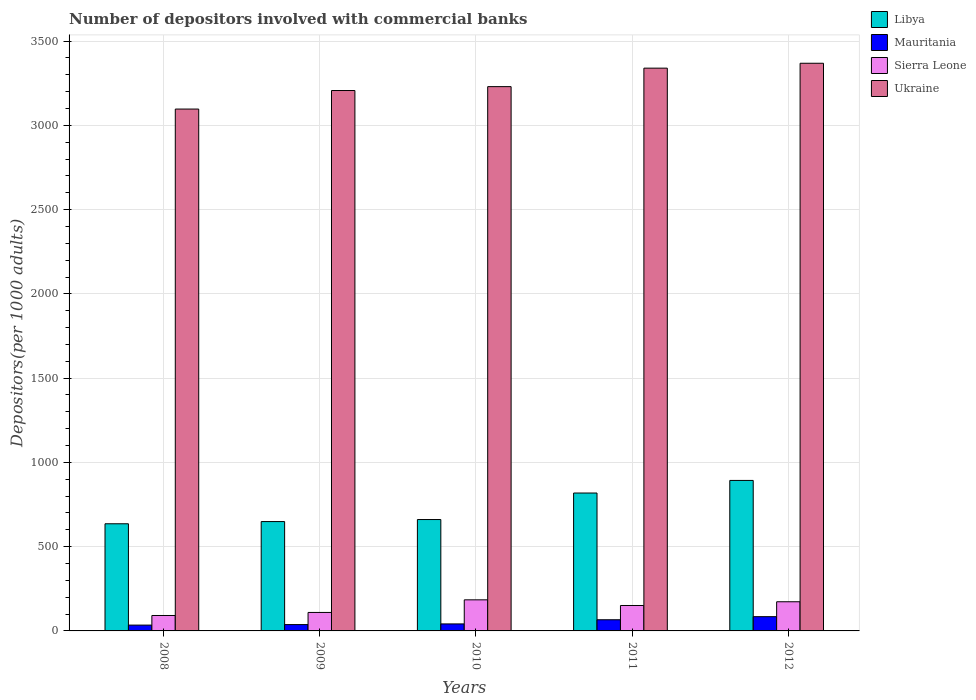How many different coloured bars are there?
Your answer should be compact. 4. Are the number of bars per tick equal to the number of legend labels?
Make the answer very short. Yes. Are the number of bars on each tick of the X-axis equal?
Provide a short and direct response. Yes. How many bars are there on the 3rd tick from the left?
Give a very brief answer. 4. What is the number of depositors involved with commercial banks in Libya in 2008?
Your answer should be very brief. 635.76. Across all years, what is the maximum number of depositors involved with commercial banks in Libya?
Offer a terse response. 892.96. Across all years, what is the minimum number of depositors involved with commercial banks in Mauritania?
Provide a succinct answer. 34.52. What is the total number of depositors involved with commercial banks in Libya in the graph?
Keep it short and to the point. 3656.76. What is the difference between the number of depositors involved with commercial banks in Libya in 2008 and that in 2012?
Offer a terse response. -257.2. What is the difference between the number of depositors involved with commercial banks in Sierra Leone in 2008 and the number of depositors involved with commercial banks in Ukraine in 2009?
Keep it short and to the point. -3115.07. What is the average number of depositors involved with commercial banks in Libya per year?
Your answer should be compact. 731.35. In the year 2009, what is the difference between the number of depositors involved with commercial banks in Ukraine and number of depositors involved with commercial banks in Libya?
Your answer should be very brief. 2557.78. What is the ratio of the number of depositors involved with commercial banks in Libya in 2008 to that in 2010?
Provide a succinct answer. 0.96. Is the number of depositors involved with commercial banks in Mauritania in 2009 less than that in 2012?
Your response must be concise. Yes. Is the difference between the number of depositors involved with commercial banks in Ukraine in 2010 and 2011 greater than the difference between the number of depositors involved with commercial banks in Libya in 2010 and 2011?
Offer a very short reply. Yes. What is the difference between the highest and the second highest number of depositors involved with commercial banks in Ukraine?
Give a very brief answer. 28.98. What is the difference between the highest and the lowest number of depositors involved with commercial banks in Sierra Leone?
Your answer should be very brief. 92.89. Is the sum of the number of depositors involved with commercial banks in Libya in 2008 and 2010 greater than the maximum number of depositors involved with commercial banks in Sierra Leone across all years?
Offer a very short reply. Yes. Is it the case that in every year, the sum of the number of depositors involved with commercial banks in Mauritania and number of depositors involved with commercial banks in Ukraine is greater than the sum of number of depositors involved with commercial banks in Libya and number of depositors involved with commercial banks in Sierra Leone?
Your response must be concise. Yes. What does the 3rd bar from the left in 2010 represents?
Keep it short and to the point. Sierra Leone. What does the 4th bar from the right in 2009 represents?
Your response must be concise. Libya. Is it the case that in every year, the sum of the number of depositors involved with commercial banks in Sierra Leone and number of depositors involved with commercial banks in Ukraine is greater than the number of depositors involved with commercial banks in Libya?
Provide a succinct answer. Yes. How many years are there in the graph?
Your answer should be very brief. 5. Are the values on the major ticks of Y-axis written in scientific E-notation?
Your answer should be compact. No. Does the graph contain grids?
Your response must be concise. Yes. How many legend labels are there?
Provide a succinct answer. 4. What is the title of the graph?
Keep it short and to the point. Number of depositors involved with commercial banks. Does "United Kingdom" appear as one of the legend labels in the graph?
Offer a terse response. No. What is the label or title of the X-axis?
Your answer should be compact. Years. What is the label or title of the Y-axis?
Your response must be concise. Depositors(per 1000 adults). What is the Depositors(per 1000 adults) in Libya in 2008?
Make the answer very short. 635.76. What is the Depositors(per 1000 adults) in Mauritania in 2008?
Provide a succinct answer. 34.52. What is the Depositors(per 1000 adults) of Sierra Leone in 2008?
Give a very brief answer. 91.57. What is the Depositors(per 1000 adults) of Ukraine in 2008?
Keep it short and to the point. 3096.67. What is the Depositors(per 1000 adults) in Libya in 2009?
Your answer should be compact. 648.86. What is the Depositors(per 1000 adults) of Mauritania in 2009?
Keep it short and to the point. 37.6. What is the Depositors(per 1000 adults) in Sierra Leone in 2009?
Ensure brevity in your answer.  109.66. What is the Depositors(per 1000 adults) in Ukraine in 2009?
Offer a very short reply. 3206.64. What is the Depositors(per 1000 adults) in Libya in 2010?
Your response must be concise. 660.95. What is the Depositors(per 1000 adults) in Mauritania in 2010?
Ensure brevity in your answer.  41.54. What is the Depositors(per 1000 adults) of Sierra Leone in 2010?
Make the answer very short. 184.46. What is the Depositors(per 1000 adults) in Ukraine in 2010?
Offer a very short reply. 3229.69. What is the Depositors(per 1000 adults) of Libya in 2011?
Provide a short and direct response. 818.23. What is the Depositors(per 1000 adults) in Mauritania in 2011?
Make the answer very short. 66.23. What is the Depositors(per 1000 adults) in Sierra Leone in 2011?
Provide a short and direct response. 150.85. What is the Depositors(per 1000 adults) of Ukraine in 2011?
Give a very brief answer. 3339.41. What is the Depositors(per 1000 adults) in Libya in 2012?
Your response must be concise. 892.96. What is the Depositors(per 1000 adults) in Mauritania in 2012?
Your answer should be compact. 84.61. What is the Depositors(per 1000 adults) of Sierra Leone in 2012?
Your response must be concise. 173.07. What is the Depositors(per 1000 adults) in Ukraine in 2012?
Give a very brief answer. 3368.39. Across all years, what is the maximum Depositors(per 1000 adults) of Libya?
Give a very brief answer. 892.96. Across all years, what is the maximum Depositors(per 1000 adults) of Mauritania?
Keep it short and to the point. 84.61. Across all years, what is the maximum Depositors(per 1000 adults) in Sierra Leone?
Offer a terse response. 184.46. Across all years, what is the maximum Depositors(per 1000 adults) of Ukraine?
Your answer should be compact. 3368.39. Across all years, what is the minimum Depositors(per 1000 adults) in Libya?
Your answer should be compact. 635.76. Across all years, what is the minimum Depositors(per 1000 adults) in Mauritania?
Ensure brevity in your answer.  34.52. Across all years, what is the minimum Depositors(per 1000 adults) of Sierra Leone?
Your answer should be very brief. 91.57. Across all years, what is the minimum Depositors(per 1000 adults) in Ukraine?
Your answer should be compact. 3096.67. What is the total Depositors(per 1000 adults) in Libya in the graph?
Provide a succinct answer. 3656.76. What is the total Depositors(per 1000 adults) of Mauritania in the graph?
Make the answer very short. 264.5. What is the total Depositors(per 1000 adults) of Sierra Leone in the graph?
Give a very brief answer. 709.61. What is the total Depositors(per 1000 adults) of Ukraine in the graph?
Your answer should be compact. 1.62e+04. What is the difference between the Depositors(per 1000 adults) in Libya in 2008 and that in 2009?
Keep it short and to the point. -13.1. What is the difference between the Depositors(per 1000 adults) of Mauritania in 2008 and that in 2009?
Offer a very short reply. -3.09. What is the difference between the Depositors(per 1000 adults) in Sierra Leone in 2008 and that in 2009?
Your answer should be very brief. -18.09. What is the difference between the Depositors(per 1000 adults) in Ukraine in 2008 and that in 2009?
Keep it short and to the point. -109.97. What is the difference between the Depositors(per 1000 adults) of Libya in 2008 and that in 2010?
Ensure brevity in your answer.  -25.19. What is the difference between the Depositors(per 1000 adults) of Mauritania in 2008 and that in 2010?
Give a very brief answer. -7.02. What is the difference between the Depositors(per 1000 adults) in Sierra Leone in 2008 and that in 2010?
Your answer should be very brief. -92.89. What is the difference between the Depositors(per 1000 adults) of Ukraine in 2008 and that in 2010?
Provide a short and direct response. -133.02. What is the difference between the Depositors(per 1000 adults) in Libya in 2008 and that in 2011?
Provide a succinct answer. -182.47. What is the difference between the Depositors(per 1000 adults) in Mauritania in 2008 and that in 2011?
Your answer should be compact. -31.71. What is the difference between the Depositors(per 1000 adults) in Sierra Leone in 2008 and that in 2011?
Offer a very short reply. -59.28. What is the difference between the Depositors(per 1000 adults) of Ukraine in 2008 and that in 2011?
Your answer should be compact. -242.74. What is the difference between the Depositors(per 1000 adults) of Libya in 2008 and that in 2012?
Keep it short and to the point. -257.2. What is the difference between the Depositors(per 1000 adults) in Mauritania in 2008 and that in 2012?
Your answer should be very brief. -50.1. What is the difference between the Depositors(per 1000 adults) of Sierra Leone in 2008 and that in 2012?
Your answer should be very brief. -81.5. What is the difference between the Depositors(per 1000 adults) of Ukraine in 2008 and that in 2012?
Offer a very short reply. -271.72. What is the difference between the Depositors(per 1000 adults) in Libya in 2009 and that in 2010?
Your response must be concise. -12.09. What is the difference between the Depositors(per 1000 adults) of Mauritania in 2009 and that in 2010?
Keep it short and to the point. -3.93. What is the difference between the Depositors(per 1000 adults) of Sierra Leone in 2009 and that in 2010?
Your answer should be compact. -74.8. What is the difference between the Depositors(per 1000 adults) in Ukraine in 2009 and that in 2010?
Ensure brevity in your answer.  -23.06. What is the difference between the Depositors(per 1000 adults) in Libya in 2009 and that in 2011?
Your response must be concise. -169.37. What is the difference between the Depositors(per 1000 adults) of Mauritania in 2009 and that in 2011?
Ensure brevity in your answer.  -28.63. What is the difference between the Depositors(per 1000 adults) in Sierra Leone in 2009 and that in 2011?
Make the answer very short. -41.18. What is the difference between the Depositors(per 1000 adults) of Ukraine in 2009 and that in 2011?
Offer a terse response. -132.77. What is the difference between the Depositors(per 1000 adults) in Libya in 2009 and that in 2012?
Ensure brevity in your answer.  -244.1. What is the difference between the Depositors(per 1000 adults) in Mauritania in 2009 and that in 2012?
Keep it short and to the point. -47.01. What is the difference between the Depositors(per 1000 adults) of Sierra Leone in 2009 and that in 2012?
Provide a succinct answer. -63.41. What is the difference between the Depositors(per 1000 adults) in Ukraine in 2009 and that in 2012?
Your response must be concise. -161.75. What is the difference between the Depositors(per 1000 adults) in Libya in 2010 and that in 2011?
Ensure brevity in your answer.  -157.27. What is the difference between the Depositors(per 1000 adults) in Mauritania in 2010 and that in 2011?
Provide a succinct answer. -24.69. What is the difference between the Depositors(per 1000 adults) of Sierra Leone in 2010 and that in 2011?
Your answer should be compact. 33.62. What is the difference between the Depositors(per 1000 adults) of Ukraine in 2010 and that in 2011?
Give a very brief answer. -109.71. What is the difference between the Depositors(per 1000 adults) in Libya in 2010 and that in 2012?
Your answer should be compact. -232. What is the difference between the Depositors(per 1000 adults) of Mauritania in 2010 and that in 2012?
Offer a terse response. -43.07. What is the difference between the Depositors(per 1000 adults) of Sierra Leone in 2010 and that in 2012?
Make the answer very short. 11.39. What is the difference between the Depositors(per 1000 adults) in Ukraine in 2010 and that in 2012?
Provide a short and direct response. -138.7. What is the difference between the Depositors(per 1000 adults) in Libya in 2011 and that in 2012?
Offer a terse response. -74.73. What is the difference between the Depositors(per 1000 adults) of Mauritania in 2011 and that in 2012?
Ensure brevity in your answer.  -18.38. What is the difference between the Depositors(per 1000 adults) in Sierra Leone in 2011 and that in 2012?
Provide a short and direct response. -22.22. What is the difference between the Depositors(per 1000 adults) of Ukraine in 2011 and that in 2012?
Offer a terse response. -28.98. What is the difference between the Depositors(per 1000 adults) of Libya in 2008 and the Depositors(per 1000 adults) of Mauritania in 2009?
Make the answer very short. 598.16. What is the difference between the Depositors(per 1000 adults) of Libya in 2008 and the Depositors(per 1000 adults) of Sierra Leone in 2009?
Keep it short and to the point. 526.1. What is the difference between the Depositors(per 1000 adults) of Libya in 2008 and the Depositors(per 1000 adults) of Ukraine in 2009?
Your response must be concise. -2570.88. What is the difference between the Depositors(per 1000 adults) in Mauritania in 2008 and the Depositors(per 1000 adults) in Sierra Leone in 2009?
Your answer should be compact. -75.15. What is the difference between the Depositors(per 1000 adults) in Mauritania in 2008 and the Depositors(per 1000 adults) in Ukraine in 2009?
Make the answer very short. -3172.12. What is the difference between the Depositors(per 1000 adults) of Sierra Leone in 2008 and the Depositors(per 1000 adults) of Ukraine in 2009?
Give a very brief answer. -3115.07. What is the difference between the Depositors(per 1000 adults) in Libya in 2008 and the Depositors(per 1000 adults) in Mauritania in 2010?
Provide a short and direct response. 594.22. What is the difference between the Depositors(per 1000 adults) in Libya in 2008 and the Depositors(per 1000 adults) in Sierra Leone in 2010?
Provide a short and direct response. 451.3. What is the difference between the Depositors(per 1000 adults) of Libya in 2008 and the Depositors(per 1000 adults) of Ukraine in 2010?
Give a very brief answer. -2593.93. What is the difference between the Depositors(per 1000 adults) of Mauritania in 2008 and the Depositors(per 1000 adults) of Sierra Leone in 2010?
Make the answer very short. -149.95. What is the difference between the Depositors(per 1000 adults) in Mauritania in 2008 and the Depositors(per 1000 adults) in Ukraine in 2010?
Your answer should be very brief. -3195.18. What is the difference between the Depositors(per 1000 adults) of Sierra Leone in 2008 and the Depositors(per 1000 adults) of Ukraine in 2010?
Your response must be concise. -3138.12. What is the difference between the Depositors(per 1000 adults) in Libya in 2008 and the Depositors(per 1000 adults) in Mauritania in 2011?
Your answer should be very brief. 569.53. What is the difference between the Depositors(per 1000 adults) in Libya in 2008 and the Depositors(per 1000 adults) in Sierra Leone in 2011?
Keep it short and to the point. 484.91. What is the difference between the Depositors(per 1000 adults) of Libya in 2008 and the Depositors(per 1000 adults) of Ukraine in 2011?
Offer a terse response. -2703.64. What is the difference between the Depositors(per 1000 adults) of Mauritania in 2008 and the Depositors(per 1000 adults) of Sierra Leone in 2011?
Ensure brevity in your answer.  -116.33. What is the difference between the Depositors(per 1000 adults) of Mauritania in 2008 and the Depositors(per 1000 adults) of Ukraine in 2011?
Your answer should be compact. -3304.89. What is the difference between the Depositors(per 1000 adults) of Sierra Leone in 2008 and the Depositors(per 1000 adults) of Ukraine in 2011?
Ensure brevity in your answer.  -3247.84. What is the difference between the Depositors(per 1000 adults) in Libya in 2008 and the Depositors(per 1000 adults) in Mauritania in 2012?
Provide a short and direct response. 551.15. What is the difference between the Depositors(per 1000 adults) in Libya in 2008 and the Depositors(per 1000 adults) in Sierra Leone in 2012?
Provide a short and direct response. 462.69. What is the difference between the Depositors(per 1000 adults) in Libya in 2008 and the Depositors(per 1000 adults) in Ukraine in 2012?
Your answer should be compact. -2732.63. What is the difference between the Depositors(per 1000 adults) in Mauritania in 2008 and the Depositors(per 1000 adults) in Sierra Leone in 2012?
Make the answer very short. -138.55. What is the difference between the Depositors(per 1000 adults) of Mauritania in 2008 and the Depositors(per 1000 adults) of Ukraine in 2012?
Provide a succinct answer. -3333.87. What is the difference between the Depositors(per 1000 adults) of Sierra Leone in 2008 and the Depositors(per 1000 adults) of Ukraine in 2012?
Your answer should be very brief. -3276.82. What is the difference between the Depositors(per 1000 adults) of Libya in 2009 and the Depositors(per 1000 adults) of Mauritania in 2010?
Offer a very short reply. 607.32. What is the difference between the Depositors(per 1000 adults) of Libya in 2009 and the Depositors(per 1000 adults) of Sierra Leone in 2010?
Your response must be concise. 464.4. What is the difference between the Depositors(per 1000 adults) of Libya in 2009 and the Depositors(per 1000 adults) of Ukraine in 2010?
Your answer should be very brief. -2580.83. What is the difference between the Depositors(per 1000 adults) of Mauritania in 2009 and the Depositors(per 1000 adults) of Sierra Leone in 2010?
Your answer should be compact. -146.86. What is the difference between the Depositors(per 1000 adults) of Mauritania in 2009 and the Depositors(per 1000 adults) of Ukraine in 2010?
Provide a succinct answer. -3192.09. What is the difference between the Depositors(per 1000 adults) in Sierra Leone in 2009 and the Depositors(per 1000 adults) in Ukraine in 2010?
Give a very brief answer. -3120.03. What is the difference between the Depositors(per 1000 adults) of Libya in 2009 and the Depositors(per 1000 adults) of Mauritania in 2011?
Offer a very short reply. 582.63. What is the difference between the Depositors(per 1000 adults) of Libya in 2009 and the Depositors(per 1000 adults) of Sierra Leone in 2011?
Your response must be concise. 498.01. What is the difference between the Depositors(per 1000 adults) in Libya in 2009 and the Depositors(per 1000 adults) in Ukraine in 2011?
Make the answer very short. -2690.54. What is the difference between the Depositors(per 1000 adults) of Mauritania in 2009 and the Depositors(per 1000 adults) of Sierra Leone in 2011?
Your response must be concise. -113.24. What is the difference between the Depositors(per 1000 adults) of Mauritania in 2009 and the Depositors(per 1000 adults) of Ukraine in 2011?
Provide a succinct answer. -3301.8. What is the difference between the Depositors(per 1000 adults) of Sierra Leone in 2009 and the Depositors(per 1000 adults) of Ukraine in 2011?
Your answer should be compact. -3229.74. What is the difference between the Depositors(per 1000 adults) of Libya in 2009 and the Depositors(per 1000 adults) of Mauritania in 2012?
Keep it short and to the point. 564.25. What is the difference between the Depositors(per 1000 adults) in Libya in 2009 and the Depositors(per 1000 adults) in Sierra Leone in 2012?
Keep it short and to the point. 475.79. What is the difference between the Depositors(per 1000 adults) in Libya in 2009 and the Depositors(per 1000 adults) in Ukraine in 2012?
Ensure brevity in your answer.  -2719.53. What is the difference between the Depositors(per 1000 adults) in Mauritania in 2009 and the Depositors(per 1000 adults) in Sierra Leone in 2012?
Give a very brief answer. -135.47. What is the difference between the Depositors(per 1000 adults) of Mauritania in 2009 and the Depositors(per 1000 adults) of Ukraine in 2012?
Your answer should be compact. -3330.79. What is the difference between the Depositors(per 1000 adults) in Sierra Leone in 2009 and the Depositors(per 1000 adults) in Ukraine in 2012?
Your answer should be compact. -3258.73. What is the difference between the Depositors(per 1000 adults) of Libya in 2010 and the Depositors(per 1000 adults) of Mauritania in 2011?
Your answer should be very brief. 594.72. What is the difference between the Depositors(per 1000 adults) in Libya in 2010 and the Depositors(per 1000 adults) in Sierra Leone in 2011?
Provide a succinct answer. 510.11. What is the difference between the Depositors(per 1000 adults) in Libya in 2010 and the Depositors(per 1000 adults) in Ukraine in 2011?
Provide a short and direct response. -2678.45. What is the difference between the Depositors(per 1000 adults) of Mauritania in 2010 and the Depositors(per 1000 adults) of Sierra Leone in 2011?
Keep it short and to the point. -109.31. What is the difference between the Depositors(per 1000 adults) in Mauritania in 2010 and the Depositors(per 1000 adults) in Ukraine in 2011?
Make the answer very short. -3297.87. What is the difference between the Depositors(per 1000 adults) in Sierra Leone in 2010 and the Depositors(per 1000 adults) in Ukraine in 2011?
Make the answer very short. -3154.94. What is the difference between the Depositors(per 1000 adults) of Libya in 2010 and the Depositors(per 1000 adults) of Mauritania in 2012?
Offer a terse response. 576.34. What is the difference between the Depositors(per 1000 adults) of Libya in 2010 and the Depositors(per 1000 adults) of Sierra Leone in 2012?
Keep it short and to the point. 487.88. What is the difference between the Depositors(per 1000 adults) of Libya in 2010 and the Depositors(per 1000 adults) of Ukraine in 2012?
Your answer should be compact. -2707.43. What is the difference between the Depositors(per 1000 adults) in Mauritania in 2010 and the Depositors(per 1000 adults) in Sierra Leone in 2012?
Offer a terse response. -131.53. What is the difference between the Depositors(per 1000 adults) in Mauritania in 2010 and the Depositors(per 1000 adults) in Ukraine in 2012?
Ensure brevity in your answer.  -3326.85. What is the difference between the Depositors(per 1000 adults) of Sierra Leone in 2010 and the Depositors(per 1000 adults) of Ukraine in 2012?
Offer a very short reply. -3183.93. What is the difference between the Depositors(per 1000 adults) in Libya in 2011 and the Depositors(per 1000 adults) in Mauritania in 2012?
Give a very brief answer. 733.62. What is the difference between the Depositors(per 1000 adults) of Libya in 2011 and the Depositors(per 1000 adults) of Sierra Leone in 2012?
Your answer should be compact. 645.16. What is the difference between the Depositors(per 1000 adults) of Libya in 2011 and the Depositors(per 1000 adults) of Ukraine in 2012?
Offer a terse response. -2550.16. What is the difference between the Depositors(per 1000 adults) of Mauritania in 2011 and the Depositors(per 1000 adults) of Sierra Leone in 2012?
Your response must be concise. -106.84. What is the difference between the Depositors(per 1000 adults) in Mauritania in 2011 and the Depositors(per 1000 adults) in Ukraine in 2012?
Offer a terse response. -3302.16. What is the difference between the Depositors(per 1000 adults) in Sierra Leone in 2011 and the Depositors(per 1000 adults) in Ukraine in 2012?
Your answer should be compact. -3217.54. What is the average Depositors(per 1000 adults) of Libya per year?
Keep it short and to the point. 731.35. What is the average Depositors(per 1000 adults) in Mauritania per year?
Give a very brief answer. 52.9. What is the average Depositors(per 1000 adults) of Sierra Leone per year?
Ensure brevity in your answer.  141.92. What is the average Depositors(per 1000 adults) in Ukraine per year?
Your answer should be very brief. 3248.16. In the year 2008, what is the difference between the Depositors(per 1000 adults) in Libya and Depositors(per 1000 adults) in Mauritania?
Ensure brevity in your answer.  601.24. In the year 2008, what is the difference between the Depositors(per 1000 adults) of Libya and Depositors(per 1000 adults) of Sierra Leone?
Your answer should be compact. 544.19. In the year 2008, what is the difference between the Depositors(per 1000 adults) of Libya and Depositors(per 1000 adults) of Ukraine?
Ensure brevity in your answer.  -2460.91. In the year 2008, what is the difference between the Depositors(per 1000 adults) in Mauritania and Depositors(per 1000 adults) in Sierra Leone?
Make the answer very short. -57.05. In the year 2008, what is the difference between the Depositors(per 1000 adults) in Mauritania and Depositors(per 1000 adults) in Ukraine?
Provide a short and direct response. -3062.15. In the year 2008, what is the difference between the Depositors(per 1000 adults) in Sierra Leone and Depositors(per 1000 adults) in Ukraine?
Your answer should be compact. -3005.1. In the year 2009, what is the difference between the Depositors(per 1000 adults) in Libya and Depositors(per 1000 adults) in Mauritania?
Provide a succinct answer. 611.26. In the year 2009, what is the difference between the Depositors(per 1000 adults) of Libya and Depositors(per 1000 adults) of Sierra Leone?
Keep it short and to the point. 539.2. In the year 2009, what is the difference between the Depositors(per 1000 adults) in Libya and Depositors(per 1000 adults) in Ukraine?
Ensure brevity in your answer.  -2557.78. In the year 2009, what is the difference between the Depositors(per 1000 adults) in Mauritania and Depositors(per 1000 adults) in Sierra Leone?
Offer a very short reply. -72.06. In the year 2009, what is the difference between the Depositors(per 1000 adults) in Mauritania and Depositors(per 1000 adults) in Ukraine?
Provide a succinct answer. -3169.03. In the year 2009, what is the difference between the Depositors(per 1000 adults) in Sierra Leone and Depositors(per 1000 adults) in Ukraine?
Provide a succinct answer. -3096.98. In the year 2010, what is the difference between the Depositors(per 1000 adults) of Libya and Depositors(per 1000 adults) of Mauritania?
Your response must be concise. 619.42. In the year 2010, what is the difference between the Depositors(per 1000 adults) of Libya and Depositors(per 1000 adults) of Sierra Leone?
Provide a succinct answer. 476.49. In the year 2010, what is the difference between the Depositors(per 1000 adults) of Libya and Depositors(per 1000 adults) of Ukraine?
Provide a short and direct response. -2568.74. In the year 2010, what is the difference between the Depositors(per 1000 adults) in Mauritania and Depositors(per 1000 adults) in Sierra Leone?
Your response must be concise. -142.93. In the year 2010, what is the difference between the Depositors(per 1000 adults) of Mauritania and Depositors(per 1000 adults) of Ukraine?
Offer a terse response. -3188.16. In the year 2010, what is the difference between the Depositors(per 1000 adults) of Sierra Leone and Depositors(per 1000 adults) of Ukraine?
Give a very brief answer. -3045.23. In the year 2011, what is the difference between the Depositors(per 1000 adults) in Libya and Depositors(per 1000 adults) in Mauritania?
Your response must be concise. 752. In the year 2011, what is the difference between the Depositors(per 1000 adults) in Libya and Depositors(per 1000 adults) in Sierra Leone?
Provide a short and direct response. 667.38. In the year 2011, what is the difference between the Depositors(per 1000 adults) in Libya and Depositors(per 1000 adults) in Ukraine?
Ensure brevity in your answer.  -2521.18. In the year 2011, what is the difference between the Depositors(per 1000 adults) in Mauritania and Depositors(per 1000 adults) in Sierra Leone?
Ensure brevity in your answer.  -84.62. In the year 2011, what is the difference between the Depositors(per 1000 adults) in Mauritania and Depositors(per 1000 adults) in Ukraine?
Ensure brevity in your answer.  -3273.18. In the year 2011, what is the difference between the Depositors(per 1000 adults) in Sierra Leone and Depositors(per 1000 adults) in Ukraine?
Give a very brief answer. -3188.56. In the year 2012, what is the difference between the Depositors(per 1000 adults) of Libya and Depositors(per 1000 adults) of Mauritania?
Provide a succinct answer. 808.34. In the year 2012, what is the difference between the Depositors(per 1000 adults) in Libya and Depositors(per 1000 adults) in Sierra Leone?
Your answer should be very brief. 719.89. In the year 2012, what is the difference between the Depositors(per 1000 adults) of Libya and Depositors(per 1000 adults) of Ukraine?
Give a very brief answer. -2475.43. In the year 2012, what is the difference between the Depositors(per 1000 adults) in Mauritania and Depositors(per 1000 adults) in Sierra Leone?
Offer a terse response. -88.46. In the year 2012, what is the difference between the Depositors(per 1000 adults) in Mauritania and Depositors(per 1000 adults) in Ukraine?
Make the answer very short. -3283.78. In the year 2012, what is the difference between the Depositors(per 1000 adults) of Sierra Leone and Depositors(per 1000 adults) of Ukraine?
Provide a short and direct response. -3195.32. What is the ratio of the Depositors(per 1000 adults) of Libya in 2008 to that in 2009?
Your response must be concise. 0.98. What is the ratio of the Depositors(per 1000 adults) of Mauritania in 2008 to that in 2009?
Provide a succinct answer. 0.92. What is the ratio of the Depositors(per 1000 adults) in Sierra Leone in 2008 to that in 2009?
Provide a succinct answer. 0.83. What is the ratio of the Depositors(per 1000 adults) in Ukraine in 2008 to that in 2009?
Your response must be concise. 0.97. What is the ratio of the Depositors(per 1000 adults) in Libya in 2008 to that in 2010?
Your answer should be compact. 0.96. What is the ratio of the Depositors(per 1000 adults) in Mauritania in 2008 to that in 2010?
Provide a short and direct response. 0.83. What is the ratio of the Depositors(per 1000 adults) in Sierra Leone in 2008 to that in 2010?
Offer a very short reply. 0.5. What is the ratio of the Depositors(per 1000 adults) in Ukraine in 2008 to that in 2010?
Your response must be concise. 0.96. What is the ratio of the Depositors(per 1000 adults) of Libya in 2008 to that in 2011?
Your answer should be compact. 0.78. What is the ratio of the Depositors(per 1000 adults) of Mauritania in 2008 to that in 2011?
Your response must be concise. 0.52. What is the ratio of the Depositors(per 1000 adults) in Sierra Leone in 2008 to that in 2011?
Ensure brevity in your answer.  0.61. What is the ratio of the Depositors(per 1000 adults) in Ukraine in 2008 to that in 2011?
Your answer should be compact. 0.93. What is the ratio of the Depositors(per 1000 adults) in Libya in 2008 to that in 2012?
Make the answer very short. 0.71. What is the ratio of the Depositors(per 1000 adults) of Mauritania in 2008 to that in 2012?
Give a very brief answer. 0.41. What is the ratio of the Depositors(per 1000 adults) in Sierra Leone in 2008 to that in 2012?
Ensure brevity in your answer.  0.53. What is the ratio of the Depositors(per 1000 adults) of Ukraine in 2008 to that in 2012?
Offer a very short reply. 0.92. What is the ratio of the Depositors(per 1000 adults) in Libya in 2009 to that in 2010?
Your answer should be compact. 0.98. What is the ratio of the Depositors(per 1000 adults) of Mauritania in 2009 to that in 2010?
Ensure brevity in your answer.  0.91. What is the ratio of the Depositors(per 1000 adults) in Sierra Leone in 2009 to that in 2010?
Ensure brevity in your answer.  0.59. What is the ratio of the Depositors(per 1000 adults) in Ukraine in 2009 to that in 2010?
Offer a terse response. 0.99. What is the ratio of the Depositors(per 1000 adults) of Libya in 2009 to that in 2011?
Offer a very short reply. 0.79. What is the ratio of the Depositors(per 1000 adults) of Mauritania in 2009 to that in 2011?
Provide a short and direct response. 0.57. What is the ratio of the Depositors(per 1000 adults) of Sierra Leone in 2009 to that in 2011?
Your answer should be very brief. 0.73. What is the ratio of the Depositors(per 1000 adults) in Ukraine in 2009 to that in 2011?
Ensure brevity in your answer.  0.96. What is the ratio of the Depositors(per 1000 adults) in Libya in 2009 to that in 2012?
Offer a terse response. 0.73. What is the ratio of the Depositors(per 1000 adults) of Mauritania in 2009 to that in 2012?
Ensure brevity in your answer.  0.44. What is the ratio of the Depositors(per 1000 adults) of Sierra Leone in 2009 to that in 2012?
Offer a terse response. 0.63. What is the ratio of the Depositors(per 1000 adults) of Libya in 2010 to that in 2011?
Provide a succinct answer. 0.81. What is the ratio of the Depositors(per 1000 adults) of Mauritania in 2010 to that in 2011?
Your response must be concise. 0.63. What is the ratio of the Depositors(per 1000 adults) in Sierra Leone in 2010 to that in 2011?
Make the answer very short. 1.22. What is the ratio of the Depositors(per 1000 adults) in Ukraine in 2010 to that in 2011?
Keep it short and to the point. 0.97. What is the ratio of the Depositors(per 1000 adults) of Libya in 2010 to that in 2012?
Your answer should be very brief. 0.74. What is the ratio of the Depositors(per 1000 adults) of Mauritania in 2010 to that in 2012?
Make the answer very short. 0.49. What is the ratio of the Depositors(per 1000 adults) of Sierra Leone in 2010 to that in 2012?
Make the answer very short. 1.07. What is the ratio of the Depositors(per 1000 adults) of Ukraine in 2010 to that in 2012?
Offer a very short reply. 0.96. What is the ratio of the Depositors(per 1000 adults) in Libya in 2011 to that in 2012?
Ensure brevity in your answer.  0.92. What is the ratio of the Depositors(per 1000 adults) of Mauritania in 2011 to that in 2012?
Give a very brief answer. 0.78. What is the ratio of the Depositors(per 1000 adults) in Sierra Leone in 2011 to that in 2012?
Keep it short and to the point. 0.87. What is the difference between the highest and the second highest Depositors(per 1000 adults) in Libya?
Offer a terse response. 74.73. What is the difference between the highest and the second highest Depositors(per 1000 adults) in Mauritania?
Make the answer very short. 18.38. What is the difference between the highest and the second highest Depositors(per 1000 adults) in Sierra Leone?
Give a very brief answer. 11.39. What is the difference between the highest and the second highest Depositors(per 1000 adults) in Ukraine?
Your response must be concise. 28.98. What is the difference between the highest and the lowest Depositors(per 1000 adults) in Libya?
Give a very brief answer. 257.2. What is the difference between the highest and the lowest Depositors(per 1000 adults) of Mauritania?
Keep it short and to the point. 50.1. What is the difference between the highest and the lowest Depositors(per 1000 adults) of Sierra Leone?
Offer a very short reply. 92.89. What is the difference between the highest and the lowest Depositors(per 1000 adults) in Ukraine?
Your response must be concise. 271.72. 